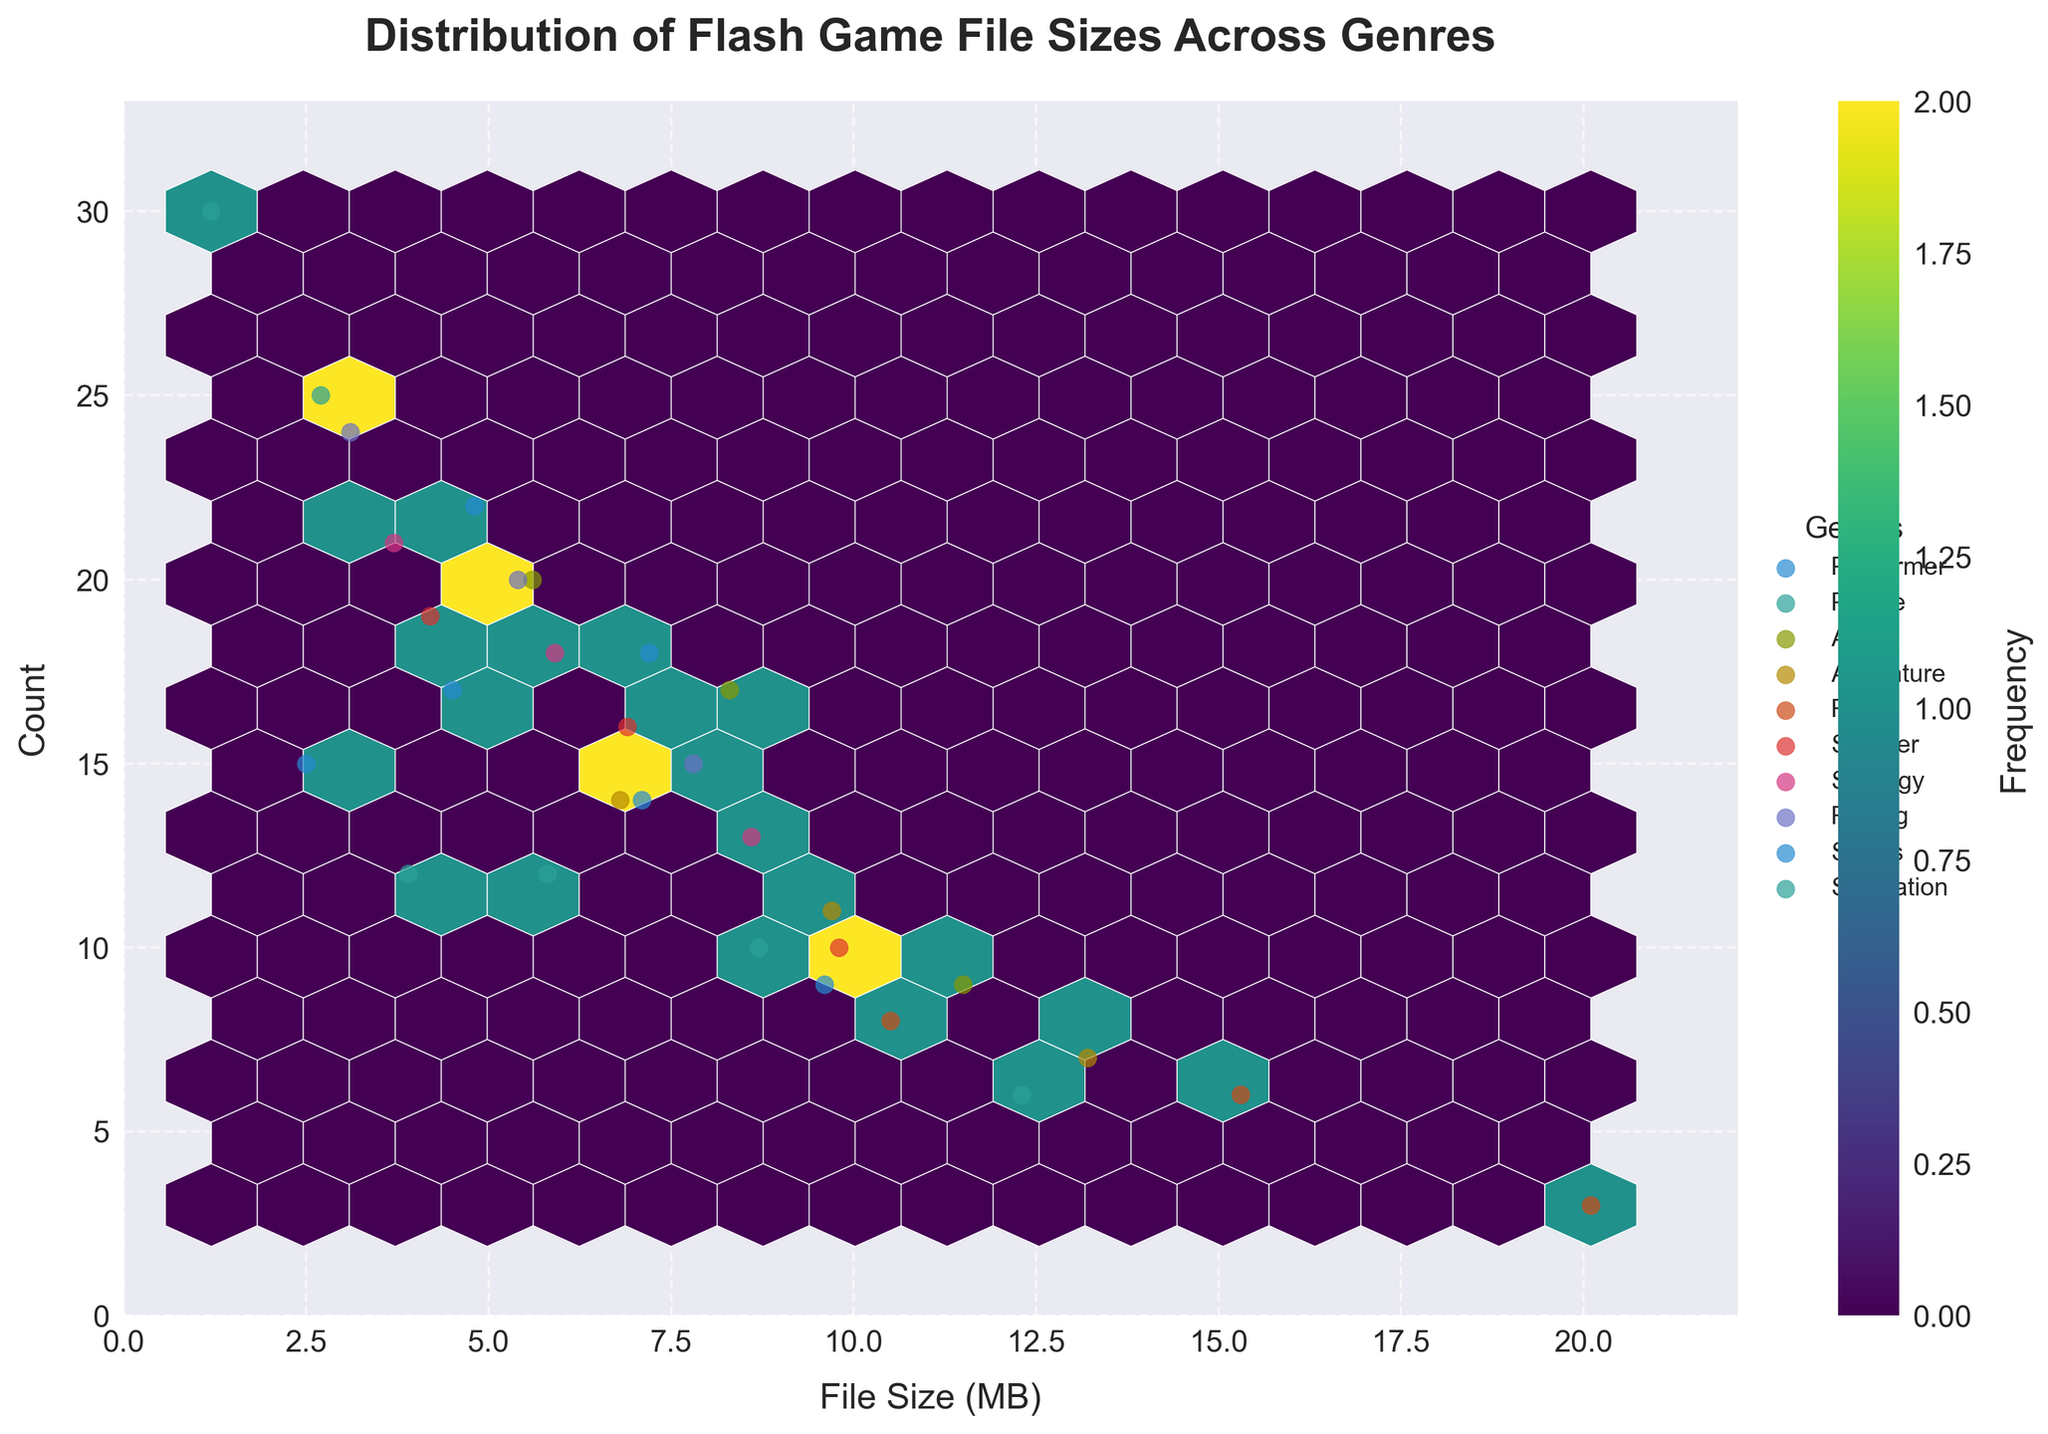What is the title of the Hexbin Plot? The title is located at the top of the plot in bold font.
Answer: Distribution of Flash Game File Sizes Across Genres What do the axes represent? The x-axis represents the File Size in MB, and the y-axis represents the Count of games.
Answer: File Size (MB) and Count Which genre has the most data points for file sizes around 5-8 MB? You need to observe the plot and the legend to see which genre has the densest clusters around the 5-8 MB file size range.
Answer: Platformer What file size range has the highest count of "Puzzle" games? Look for the clusters of hexagons with high frequency around the y-axis between the specified ranges where Puzzle games are plotted.
Answer: 1.2-3.9 MB Compare the file size distribution between "Action" and "RPG" games. Which genre generally has larger file sizes? Identify the clusters for Action and RPG from the legend. Action games are clustered around smaller file sizes while RPG games show larger file sizes.
Answer: RPG What color represents the highest frequency of data points in the plot? Check the color bar on the right side of the plot. The darkest color indicates the highest frequency.
Answer: Dark green Between genres "Adventure" and "Strategy," which one has higher overall game count for sizes around 6-9 MB? Find clusters for Adventure and Strategy genres, then compare their frequency around 6-9 MB.
Answer: Adventure What's the maximum file size for Sports games in the plot? Look at the data points for Sports games and find the maximum value on the x-axis for this genre.
Answer: 9.6 MB How many genres have game counts that go above 15? Analyze the data points across different genres and count the genres where the y-values exceed 15.
Answer: 6 genres What does the color bar's label indicate? The color bar's label typically indicates what the color gradient stands for.
Answer: Frequency 